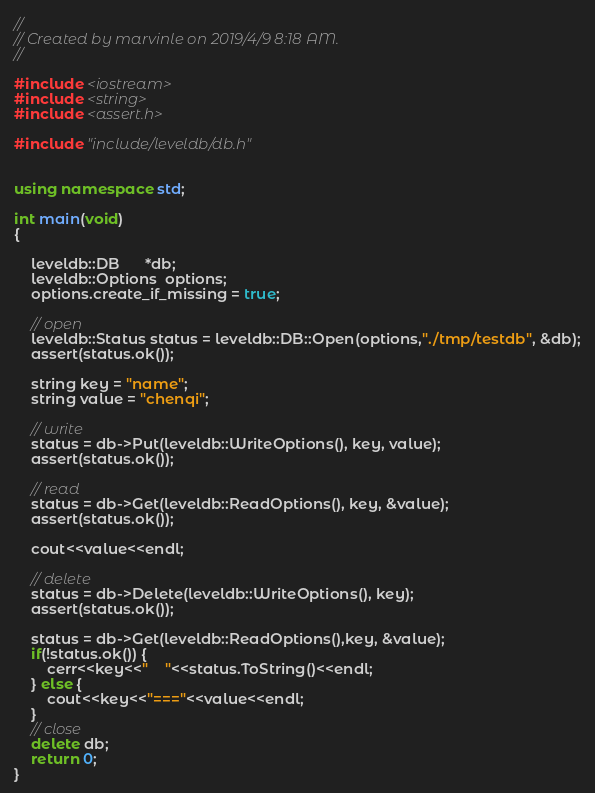<code> <loc_0><loc_0><loc_500><loc_500><_C++_>//
// Created by marvinle on 2019/4/9 8:18 AM.
//

#include <iostream>
#include <string>
#include <assert.h>

#include "include/leveldb/db.h"


using namespace std;

int main(void)
{

    leveldb::DB      *db;
    leveldb::Options  options;
    options.create_if_missing = true;

    // open
    leveldb::Status status = leveldb::DB::Open(options,"./tmp/testdb", &db);
    assert(status.ok());

    string key = "name";
    string value = "chenqi";

    // write
    status = db->Put(leveldb::WriteOptions(), key, value);
    assert(status.ok());

    // read
    status = db->Get(leveldb::ReadOptions(), key, &value);
    assert(status.ok());

    cout<<value<<endl;

    // delete
    status = db->Delete(leveldb::WriteOptions(), key);
    assert(status.ok());

    status = db->Get(leveldb::ReadOptions(),key, &value);
    if(!status.ok()) {
        cerr<<key<<"    "<<status.ToString()<<endl;
    } else {
        cout<<key<<"==="<<value<<endl;
    }
    // close
    delete db;
    return 0;
}</code> 